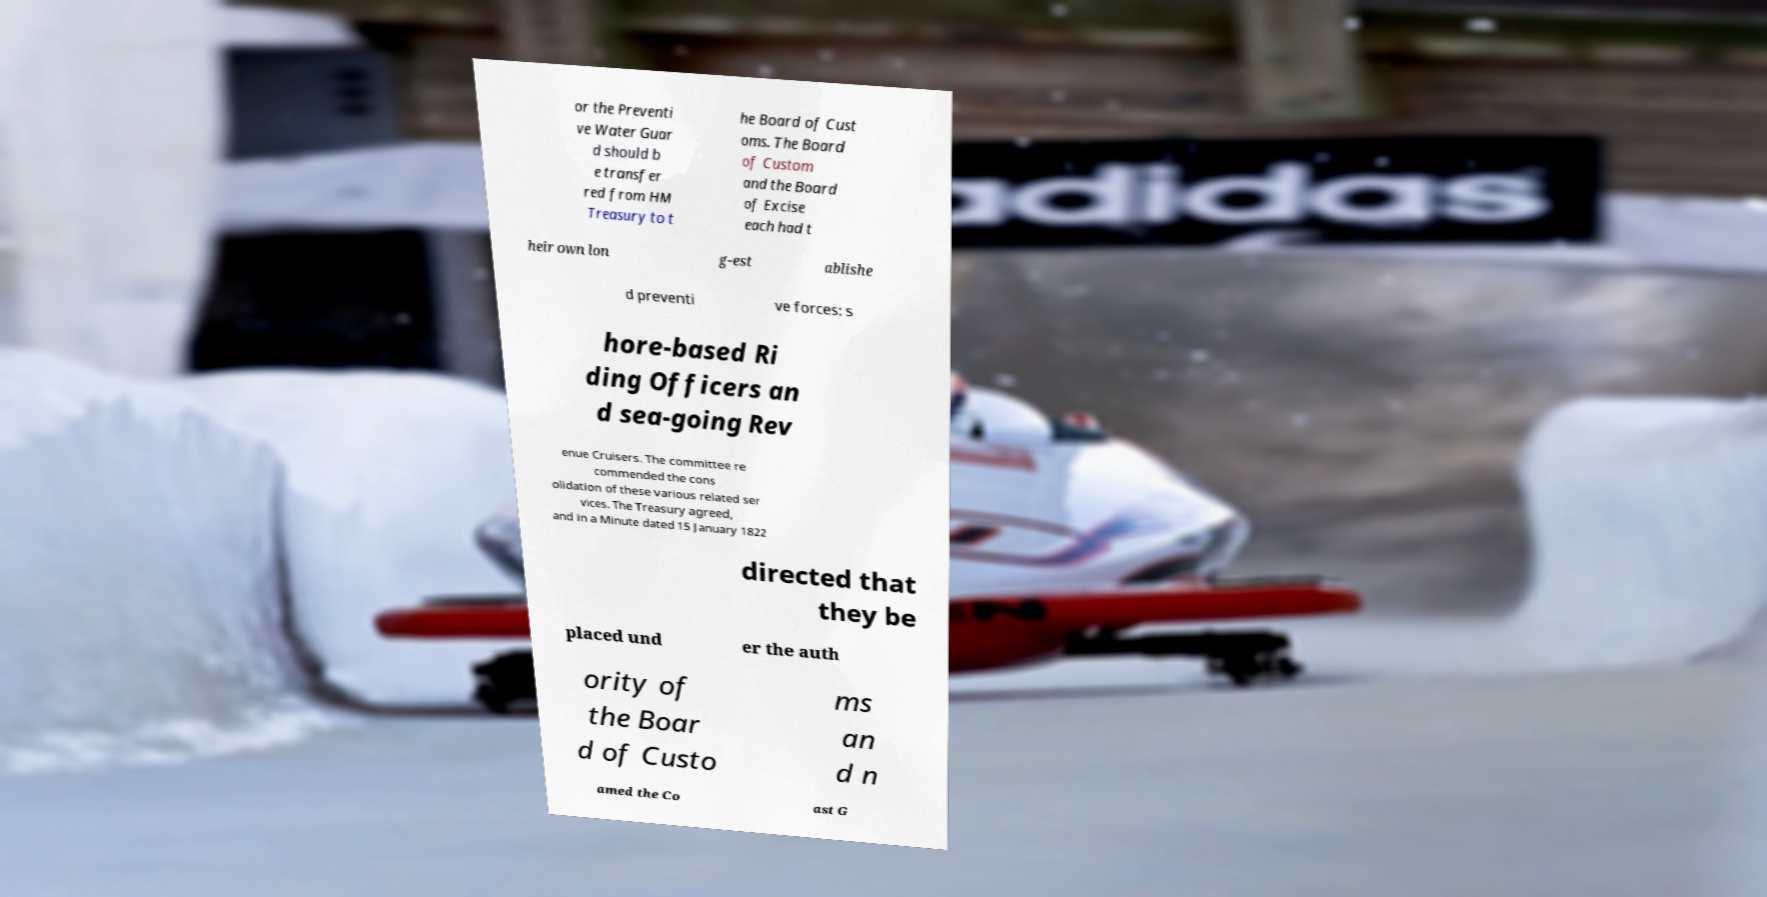I need the written content from this picture converted into text. Can you do that? or the Preventi ve Water Guar d should b e transfer red from HM Treasury to t he Board of Cust oms. The Board of Custom and the Board of Excise each had t heir own lon g-est ablishe d preventi ve forces: s hore-based Ri ding Officers an d sea-going Rev enue Cruisers. The committee re commended the cons olidation of these various related ser vices. The Treasury agreed, and in a Minute dated 15 January 1822 directed that they be placed und er the auth ority of the Boar d of Custo ms an d n amed the Co ast G 